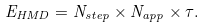Convert formula to latex. <formula><loc_0><loc_0><loc_500><loc_500>E _ { H M D } = N _ { s t e p } \times N _ { a p p } \times \tau .</formula> 